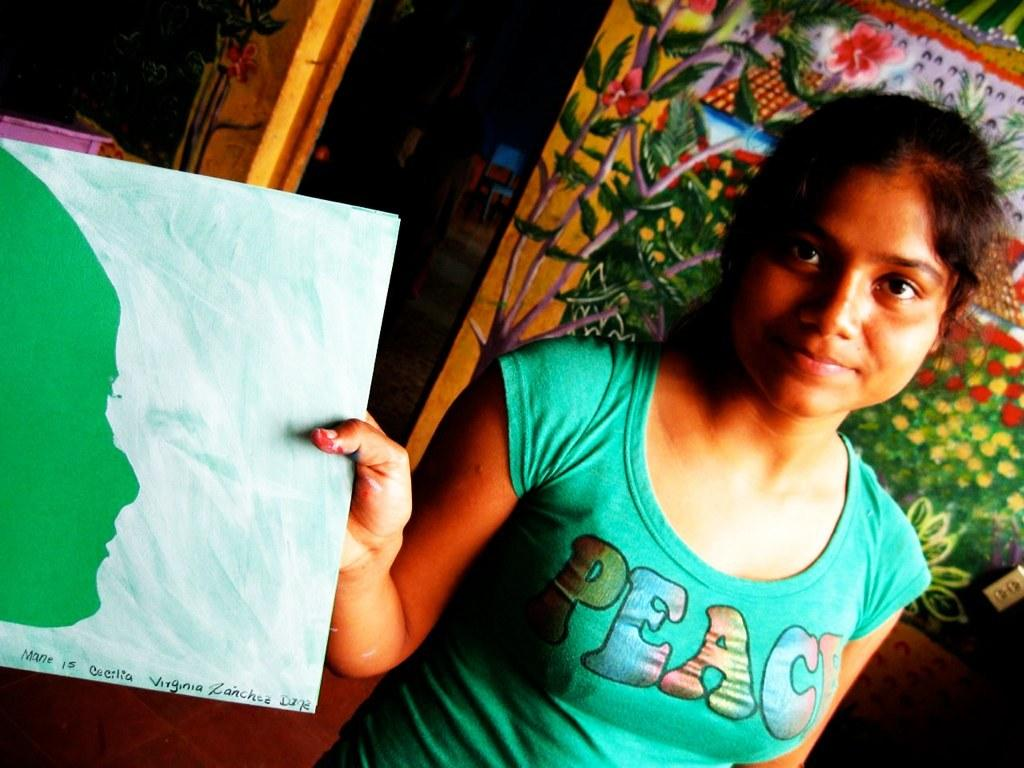What is the person in the image holding? The person is holding an object in the image. Can you describe the object? The object is painted and has text written on it. What can be seen in the background of the image? There is a banner with different colors in the background of the image. What type of beef is being cooked on the grill in the image? There is no grill or beef present in the image; it features a person holding a painted object with text and a banner in the background. 